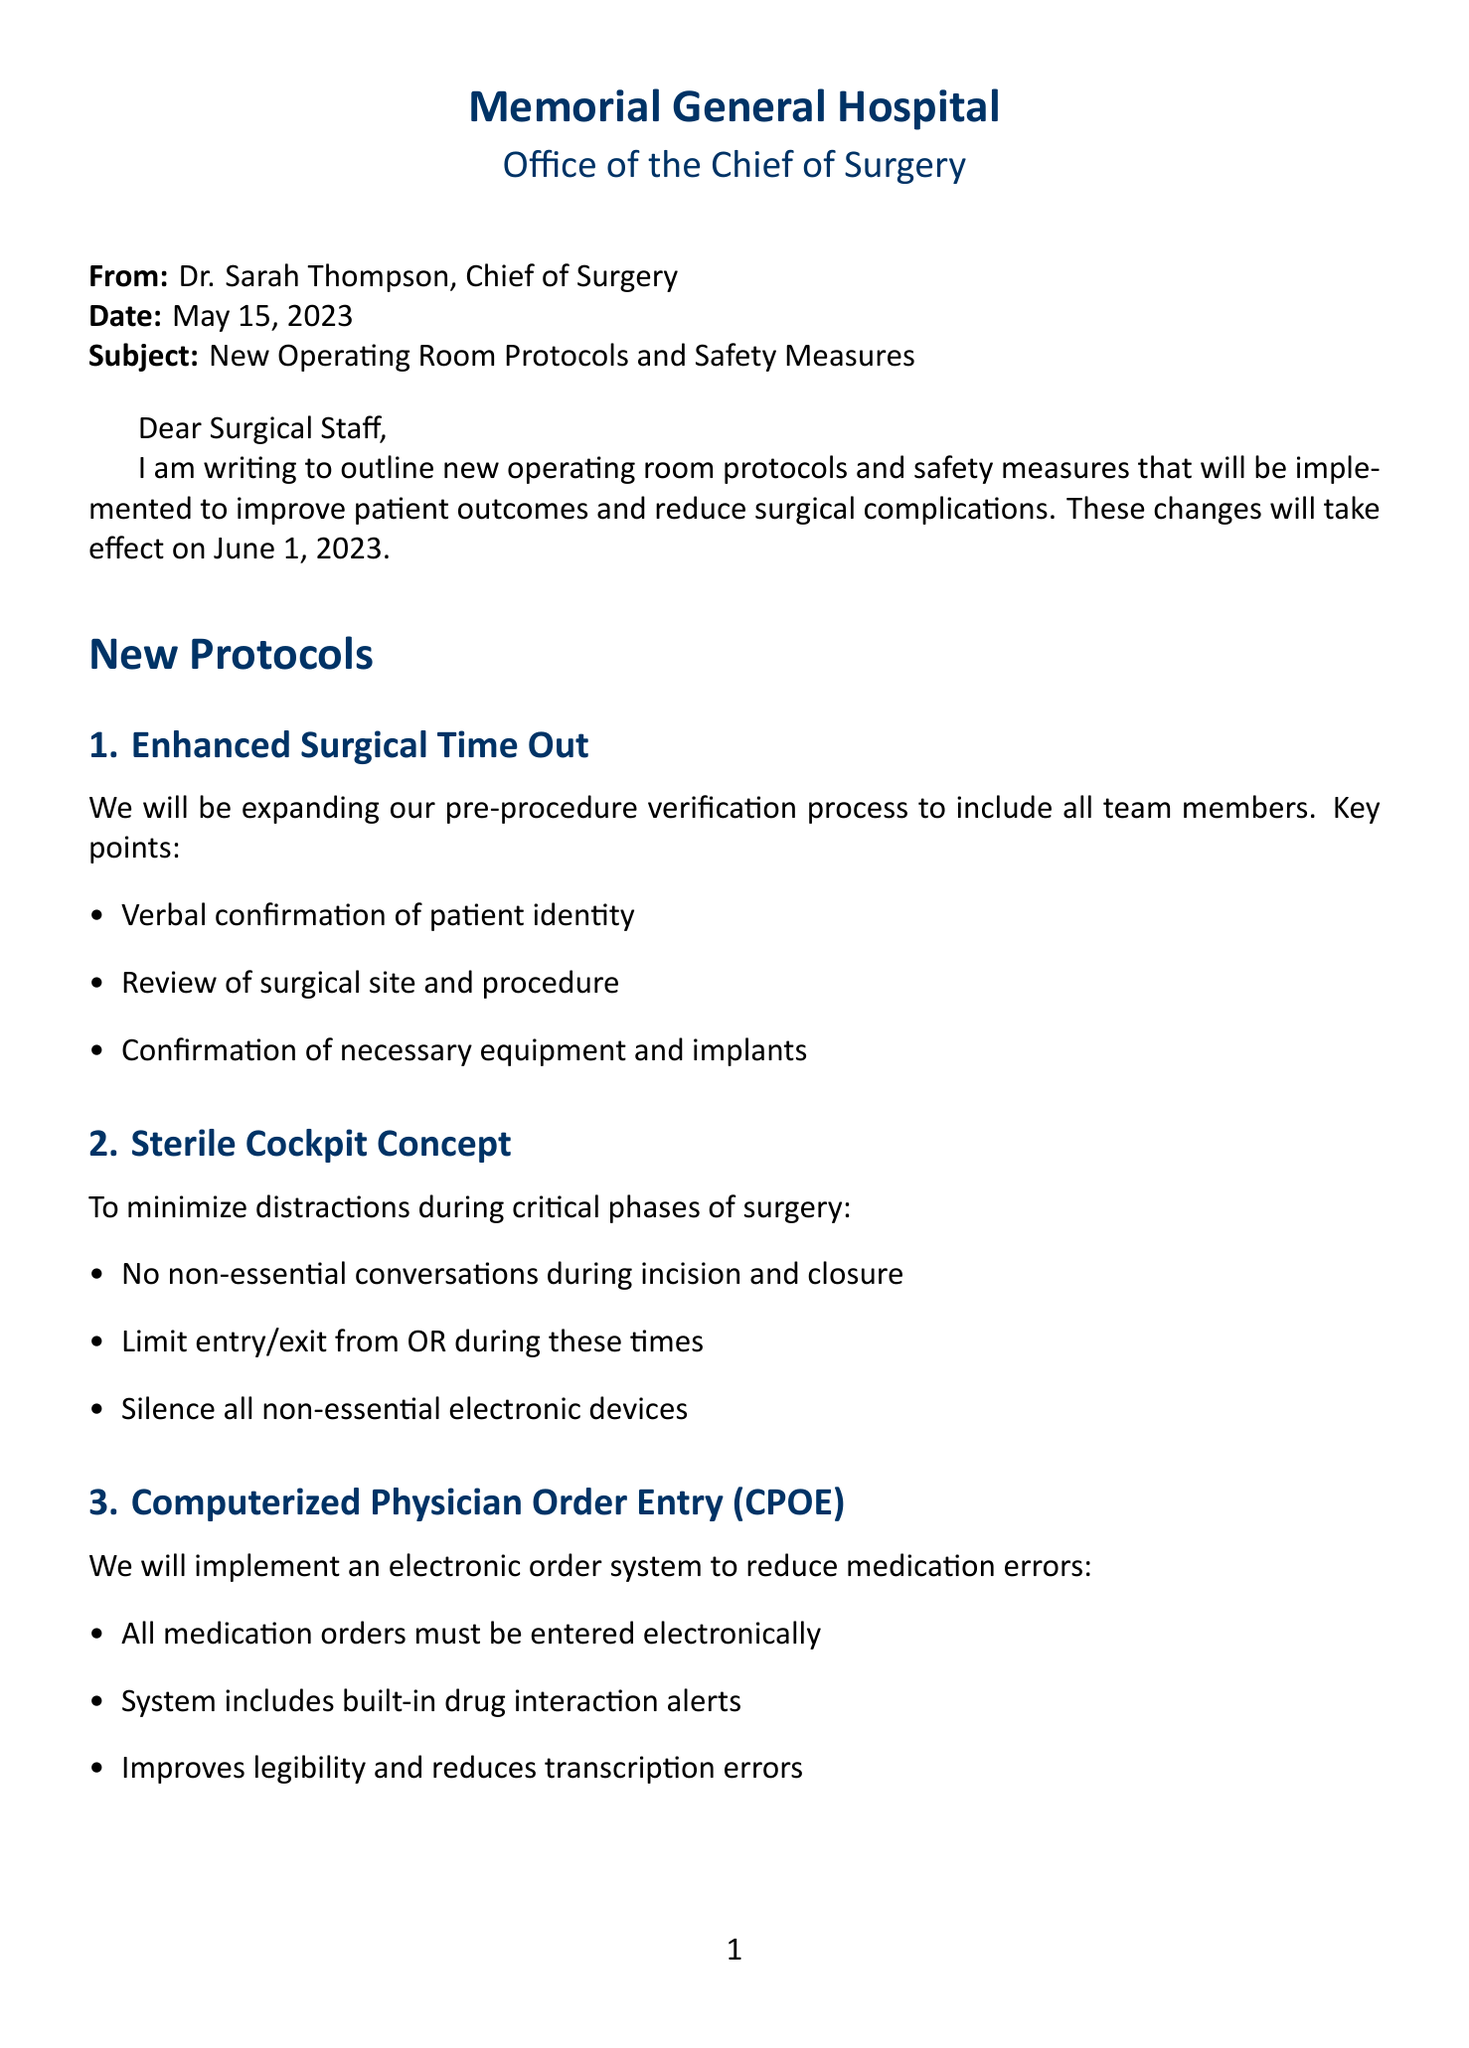what is the name of the Chief of Surgery? The document states that Dr. Sarah Thompson is the Chief of Surgery at Memorial General Hospital.
Answer: Dr. Sarah Thompson what is the date these new protocols will be implemented? The letter specifies that the new operating room protocols will take effect on June 1, 2023.
Answer: June 1, 2023 what is one of the key points of the Enhanced Surgical Time Out? The document lists that a key point of the Enhanced Surgical Time Out is the verbal confirmation of patient identity.
Answer: Verbal confirmation of patient identity how many sessions will be provided for training and support? The letter mentions three types of sessions focusing on different aspects of training and support.
Answer: Three what is one benefit of the UV-C Disinfection System? The document outlines that one benefit is that it reduces bacterial contamination.
Answer: Reduces bacterial contamination what measures are taken for compliance monitoring? The letter states that random audits of operating room procedures will be conducted for compliance.
Answer: Random audits what update is included in the Enhanced PPE Guidelines? The letter describes double gloving for all invasive procedures as one of the updates in PPE guidelines.
Answer: Double gloving for all invasive procedures how are monthly compliance reports shared with staff? The document specifies that monthly compliance reports will be shared with all surgical staff to ensure adherence.
Answer: Shared with all surgical staff 